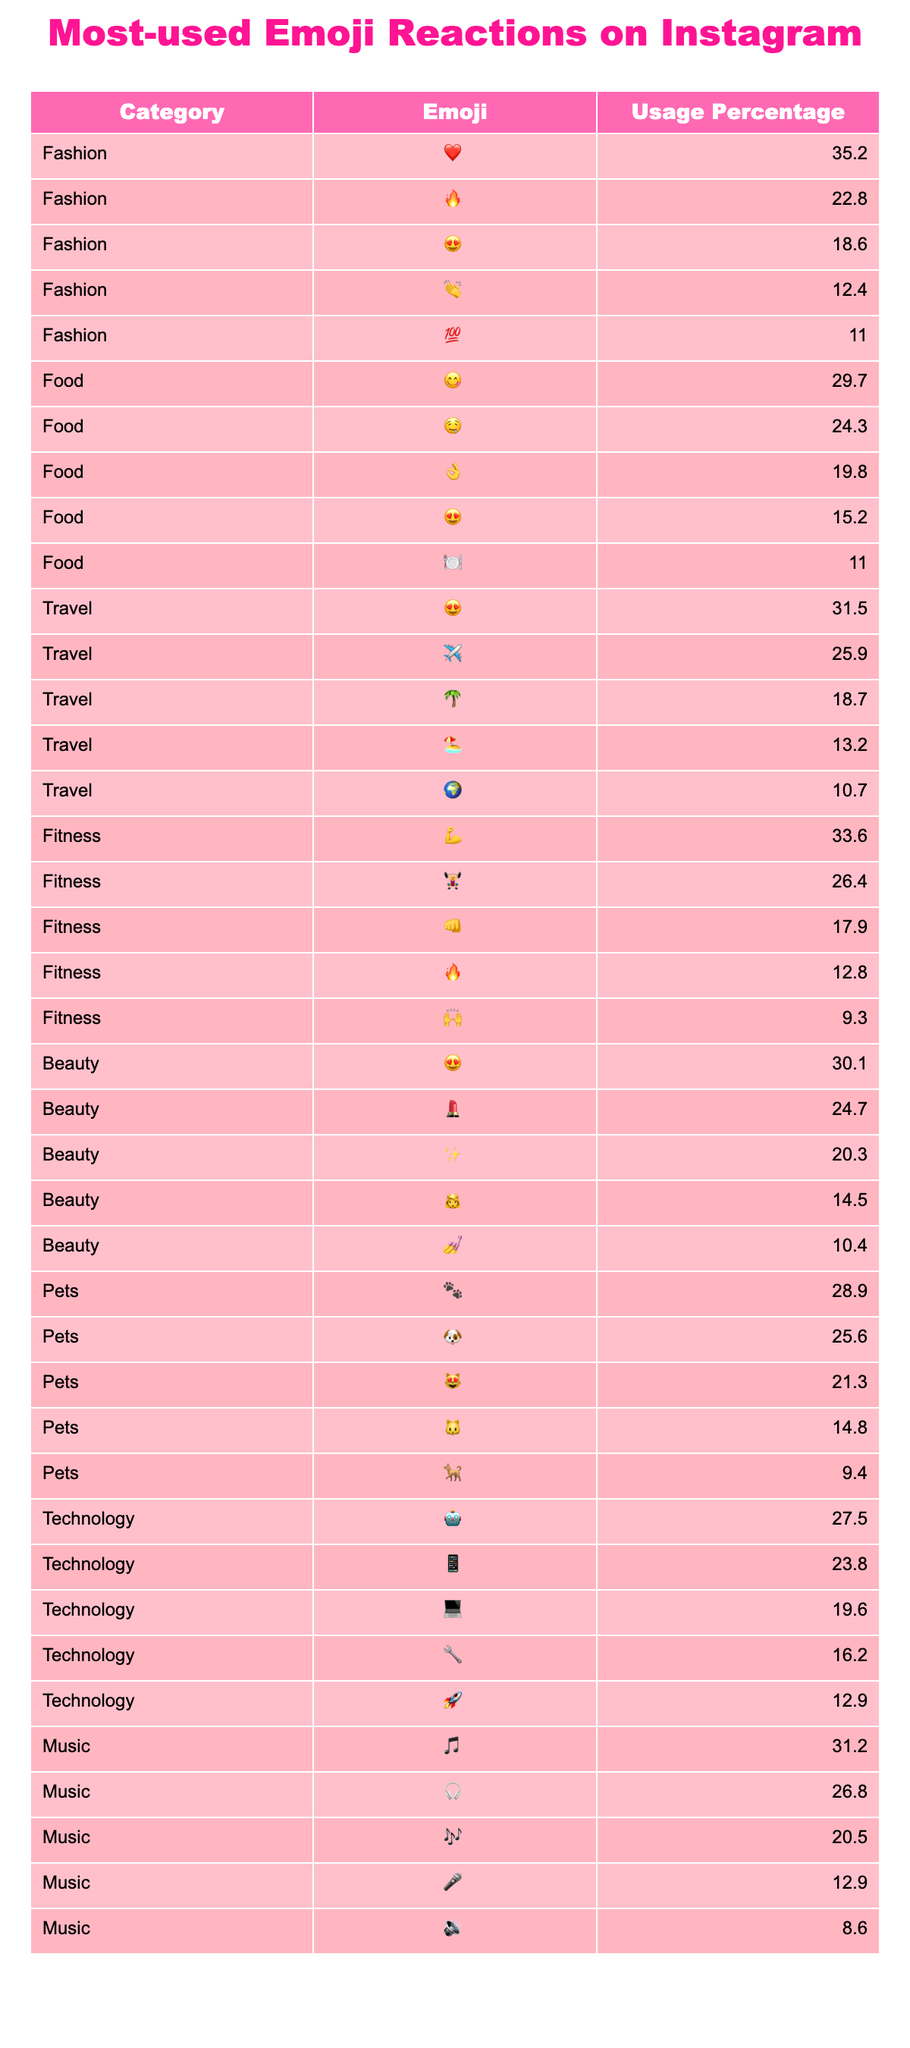What's the most-used emoji in the Fashion category? From the table, the emoji with the highest usage percentage in the Fashion category is ❤️, which has a usage percentage of 35.2%.
Answer: ❤️ Which emoji is the second most popular reaction for Food posts? In the Food category, the second most popular emoji reaction is 🤤, with a usage percentage of 24.3%.
Answer: 🤤 Is the usage of the 💪 emoji in Fitness greater than the usage of the 😻 emoji in Pets? The usage percentage for 💪 in Fitness is 33.6% and for 😻 in Pets is 21.3%. Since 33.6% is greater than 21.3%, the statement is true.
Answer: Yes What's the total usage percentage of the top two emojis in the Travel category? The top two emojis in the Travel category are 😍 with 31.5% and ✈️ with 25.9%. Adding these gives 31.5% + 25.9% = 57.4%.
Answer: 57.4% Which category has the emoji with the lowest percentage of use? The emoji with the lowest percentage in the table is 🔊 from the Music category, with a usage percentage of 8.6%.
Answer: 🔊 What is the median usage percentage of emojis in the Fitness category? The usage percentages for Fitness are 33.6%, 26.4%, 17.9%, 12.8%, and 9.3%. When sorted, the middle value is 17.9%, making it the median.
Answer: 17.9% Which category has the highest overall engagement based on the top emoji and what is the percentage? By comparing the top emojis from each category, Fashion has 35.2%, Food has 29.7%, Travel has 31.5%, Fitness has 33.6%, Beauty has 30.1%, Pets has 28.9%, Technology has 27.5%, and Music has 31.2%. The highest is Fashion at 35.2%.
Answer: Fashion, 35.2% If you sum the usage percentages of the top three emojis in the Beauty category, what will be the total? The top three emojis in Beauty are 😍 (30.1%), 💄 (24.7%), and ✨ (20.3%). Adding these gives 30.1% + 24.7% + 20.3% = 75.1%.
Answer: 75.1% 